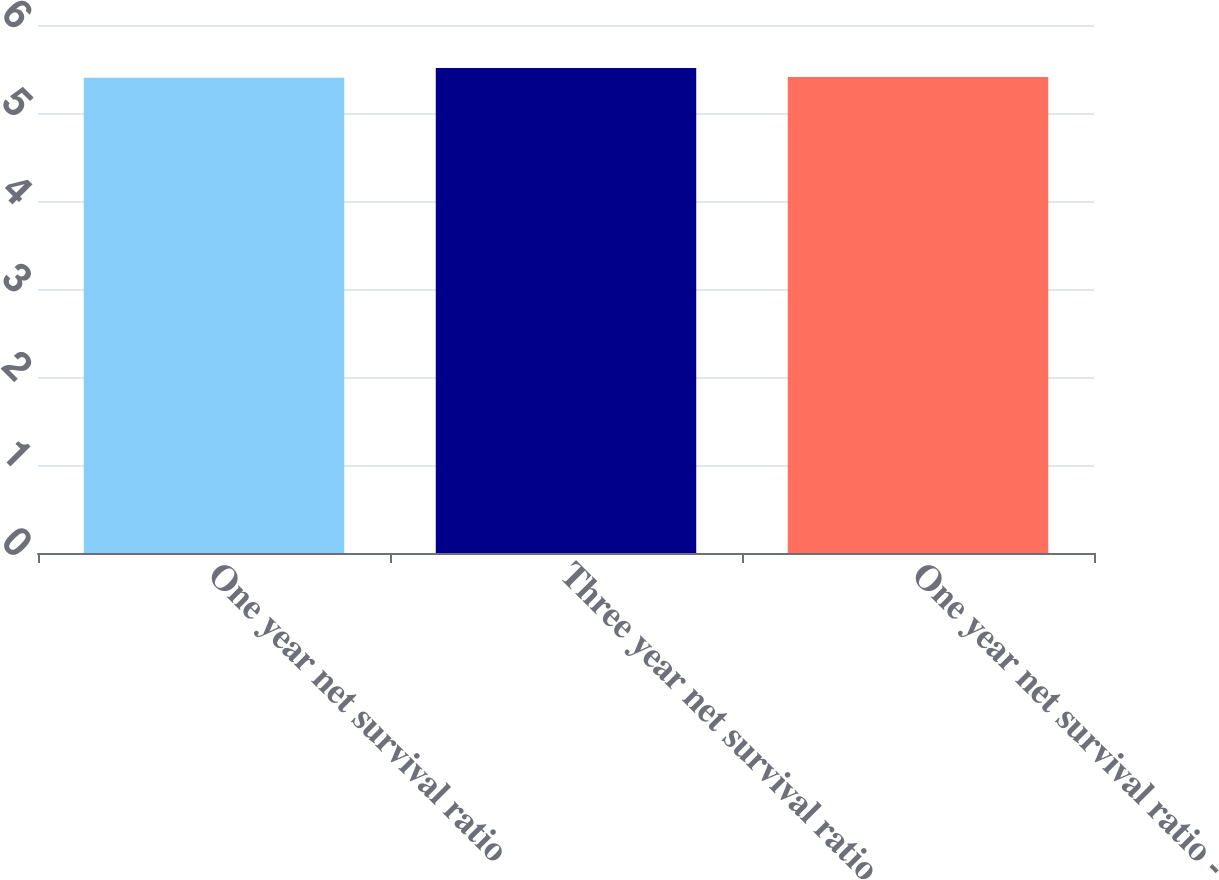<chart> <loc_0><loc_0><loc_500><loc_500><bar_chart><fcel>One year net survival ratio<fcel>Three year net survival ratio<fcel>One year net survival ratio -<nl><fcel>5.4<fcel>5.51<fcel>5.41<nl></chart> 